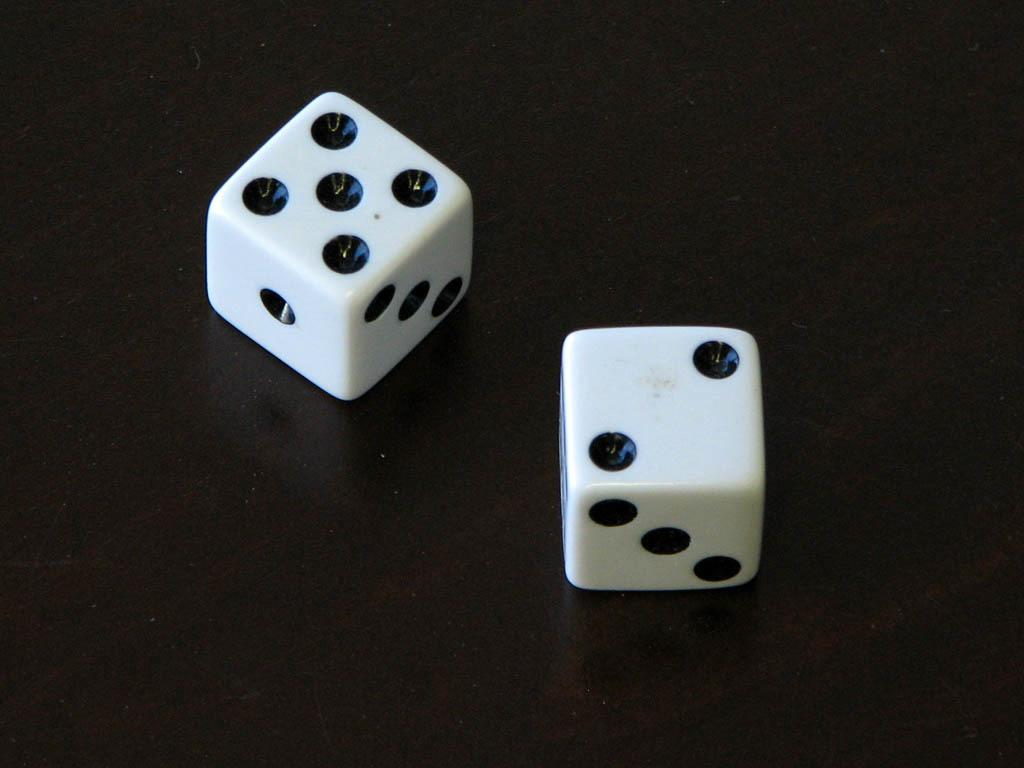What objects are present in the image? There are two dice in the image. What colors are the dice? One die is white, and the other is black. What is the color of the background in the image? The background of the image is black. What type of wound can be seen on the white die in the image? There is no wound present on the white die or any other object in the image. 